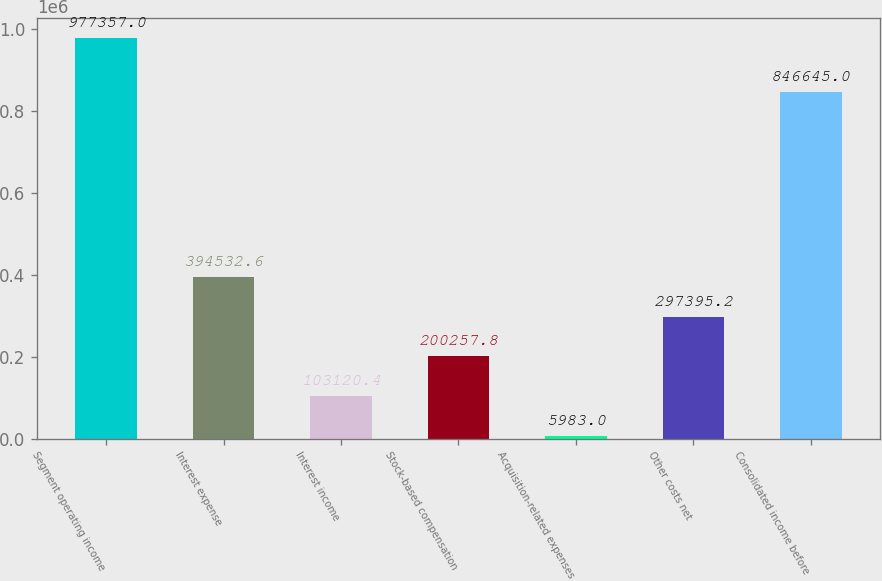Convert chart. <chart><loc_0><loc_0><loc_500><loc_500><bar_chart><fcel>Segment operating income<fcel>Interest expense<fcel>Interest income<fcel>Stock-based compensation<fcel>Acquisition-related expenses<fcel>Other costs net<fcel>Consolidated income before<nl><fcel>977357<fcel>394533<fcel>103120<fcel>200258<fcel>5983<fcel>297395<fcel>846645<nl></chart> 